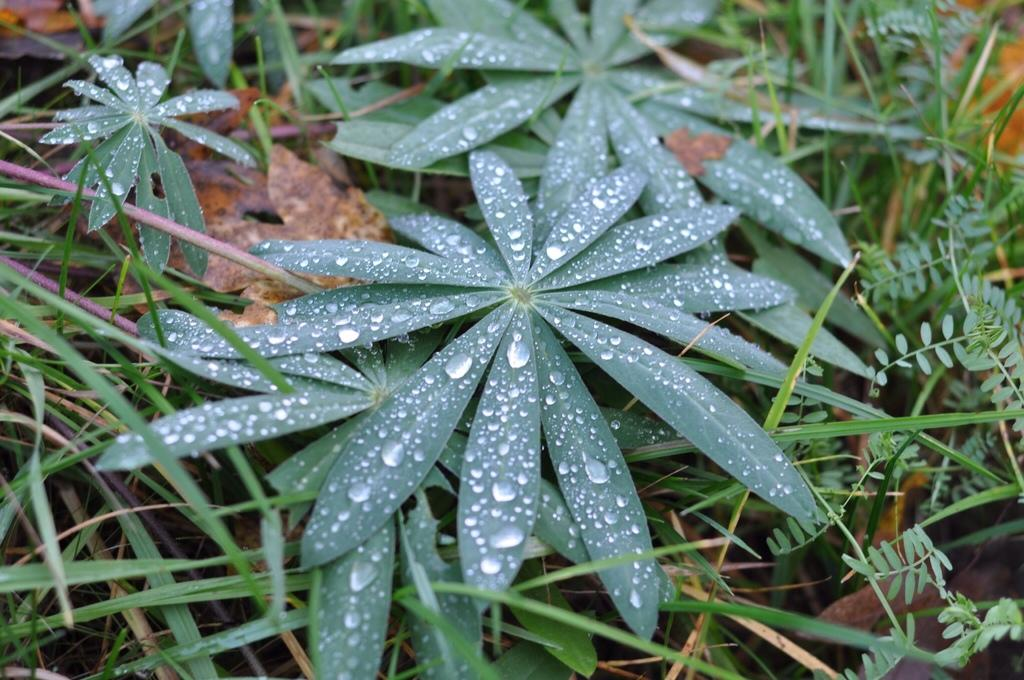What type of living organisms can be seen in the image? Plants and grass are visible in the image. Can you describe the natural setting visible in the picture? The natural setting includes plants and grass. What type of fan can be seen in the image? There is no fan present in the image. What kind of paste is being used on the plants in the image? There is no paste being used on the plants in the image. 